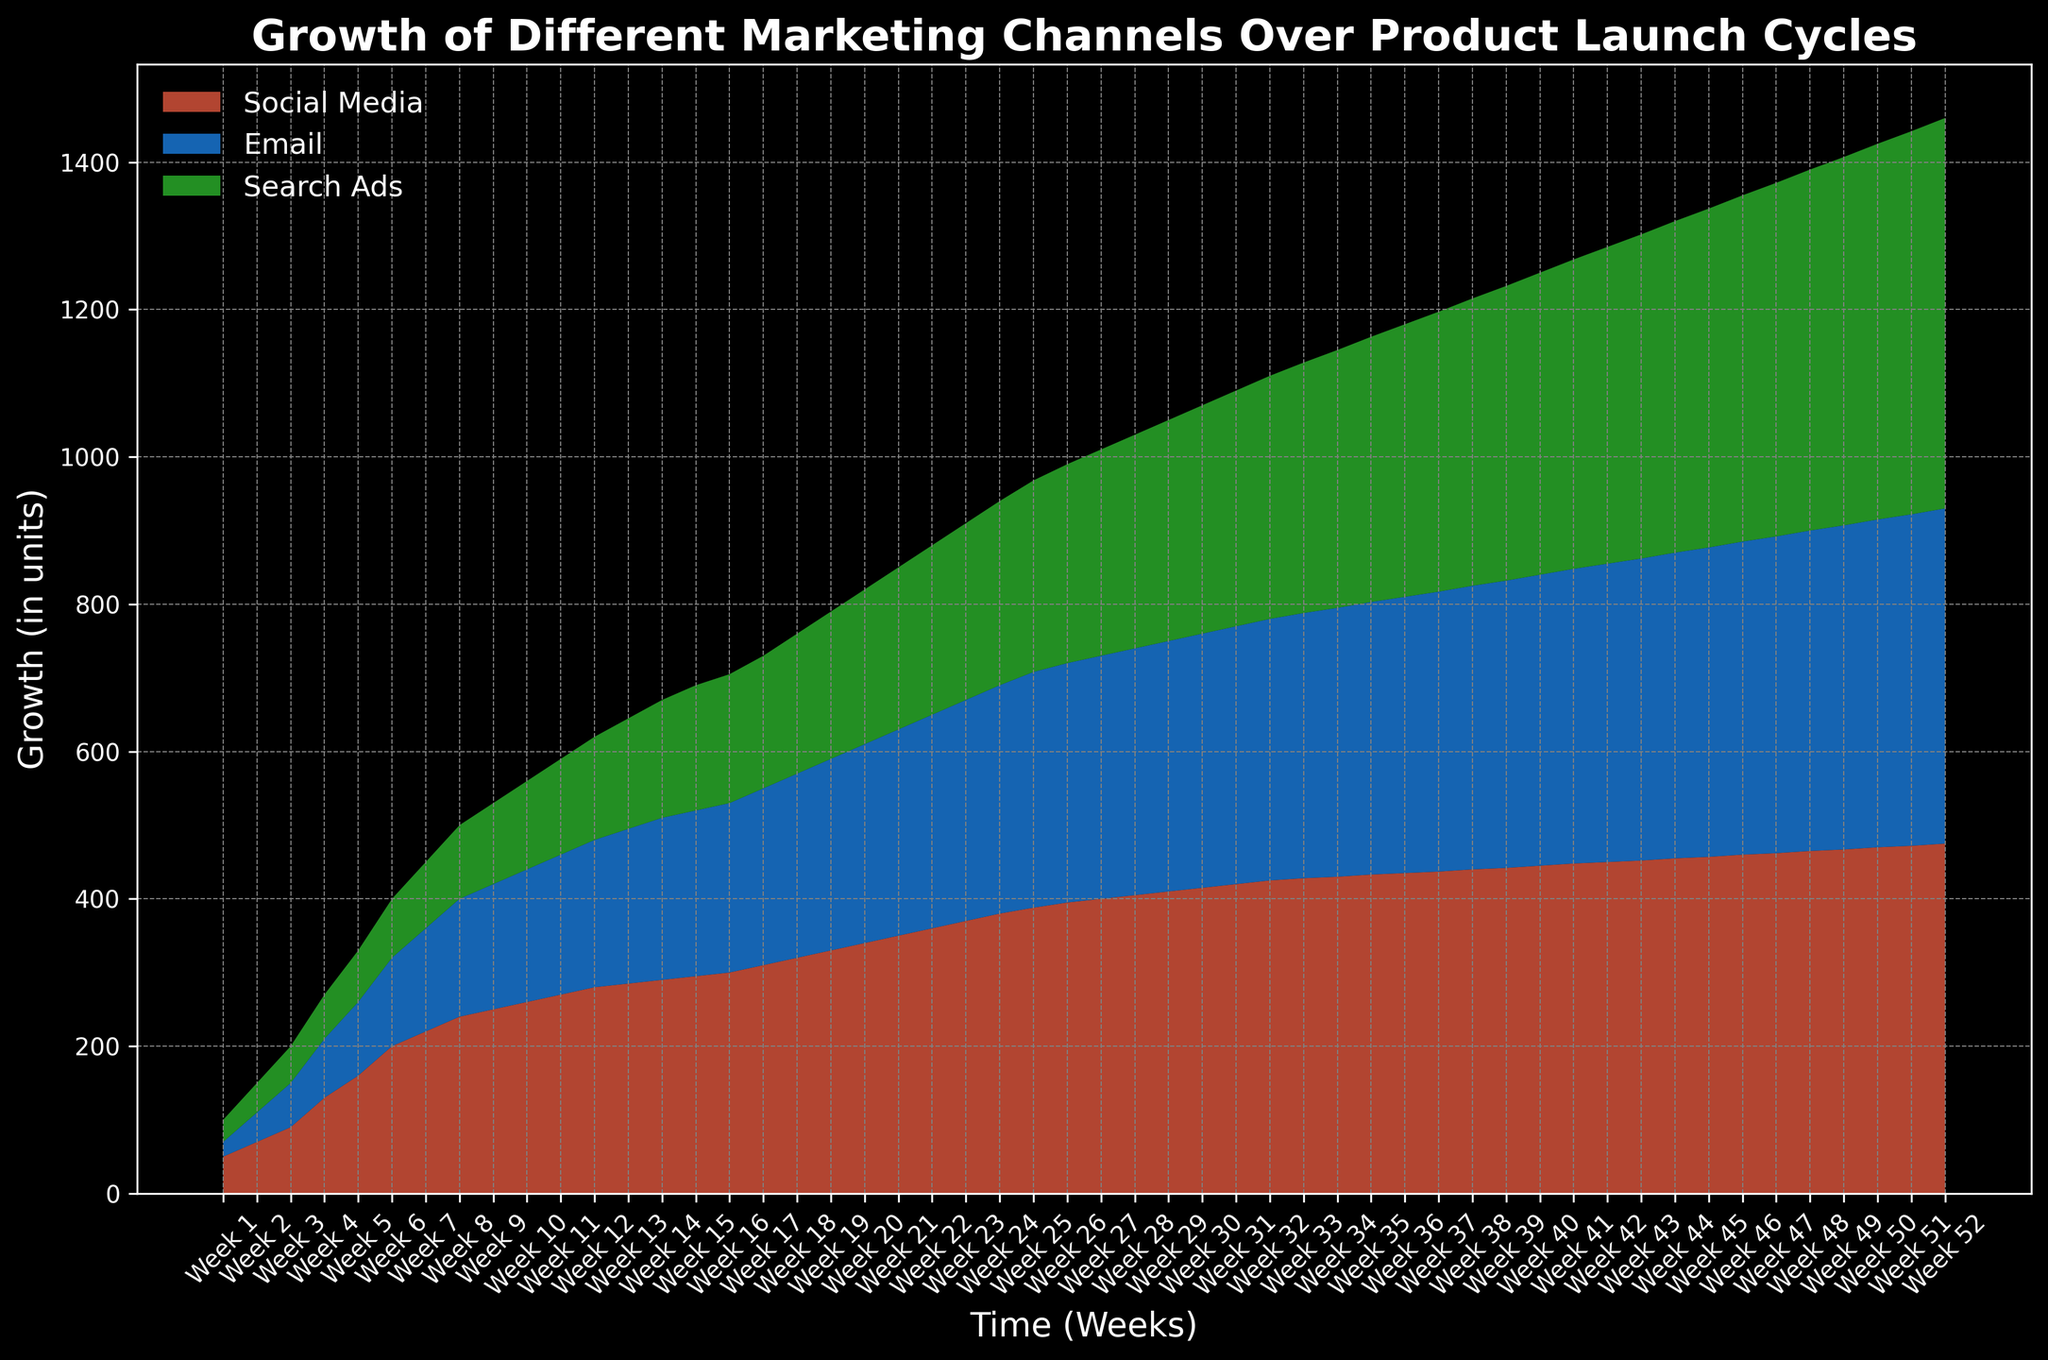What marketing channel shows the highest growth at Week 25? At Week 25, look at the area for each marketing channel. The Social Media area reaches about 388 units, which is the highest compared to Email (320 units) and Search Ads (260 units).
Answer: Social Media How does the growth of Email compare with Search Ads at Week 15? At Week 15, looking at the heights of the stacked areas, Email is around 225 units, whereas Search Ads is around 170 units. Therefore, Email has higher growth than Search Ads at this point.
Answer: Email What is the difference in growth between Social Media and Search Ads at Week 10? At Week 10, Social Media is at 260 units and Search Ads is at 120 units. The difference can be calculated as 260 - 120 = 140 units.
Answer: 140 units Which marketing channel consistently shows the highest growth over the product launch cycle? Observing the entire area chart, Social Media consistently remains the highest layer, indicating the highest growth over the whole period.
Answer: Social Media What is the total growth for all marketing channels at Week 52? At Week 52, sum the heights of all layers: Social Media (475 units), Email (455 units), and Search Ads (530 units). The total growth is 475 + 455 + 530 = 1460 units.
Answer: 1460 units During which week does Email's growth surpass 400 units? Observe the area representing Email and track its growth. Email's growth exceeds 400 units at Week 39.
Answer: Week 39 What color represents Search Ads, and what is its growth trend over time? Search Ads is represented in green. Following the green area, it expands consistently over the product launch cycles, showing continuous growth.
Answer: Green, Continuous growth Is there any week where all three marketing channels have the same growth value? By scanning the figure, there is no week where Social Media, Email, and Search Ads have matching values; Social Media always leads, followed by Email and then Search Ads.
Answer: No Between Weeks 20 and 30, which marketing channel has the steepest growth? Between Weeks 20 and 30, observe the steepness of each area. Social Media shows the steepest upward slope compared to Email and Search Ads, indicating the highest rate of growth.
Answer: Social Media 